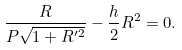<formula> <loc_0><loc_0><loc_500><loc_500>\frac { R } { P \sqrt { 1 + R ^ { \prime 2 } } } - \frac { h } { 2 } R ^ { 2 } = 0 .</formula> 